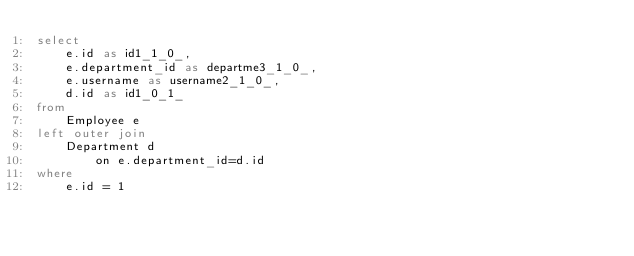<code> <loc_0><loc_0><loc_500><loc_500><_SQL_>select
    e.id as id1_1_0_,
    e.department_id as departme3_1_0_,
    e.username as username2_1_0_,
    d.id as id1_0_1_ 
from
    Employee e 
left outer join
    Department d 
        on e.department_id=d.id 
where
    e.id = 1</code> 